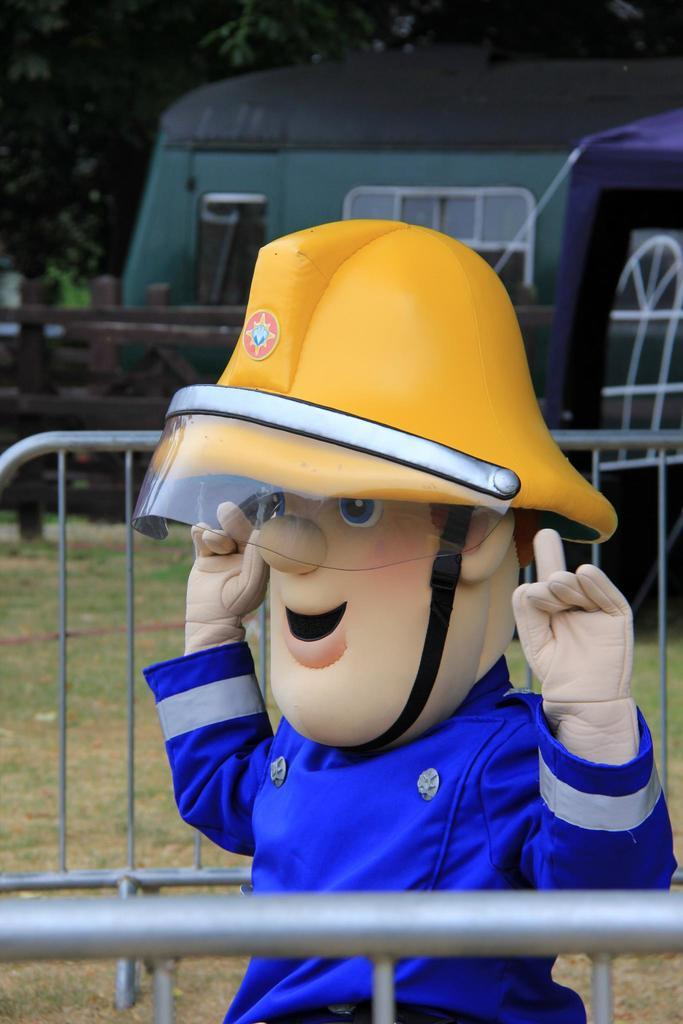What is the main object in the image? There is an inflatable doll in the image. What surrounds the doll? There is a metal fence around the doll. What can be seen in the background of the image? There is a tent and trees in the background of the image. How are the trees situated in relation to the wooden fence? The trees are inside a wooden fence. What type of pollution can be seen in the image? There is no pollution visible in the image. How does the tank contribute to the scene in the image? There is no tank present in the image. 